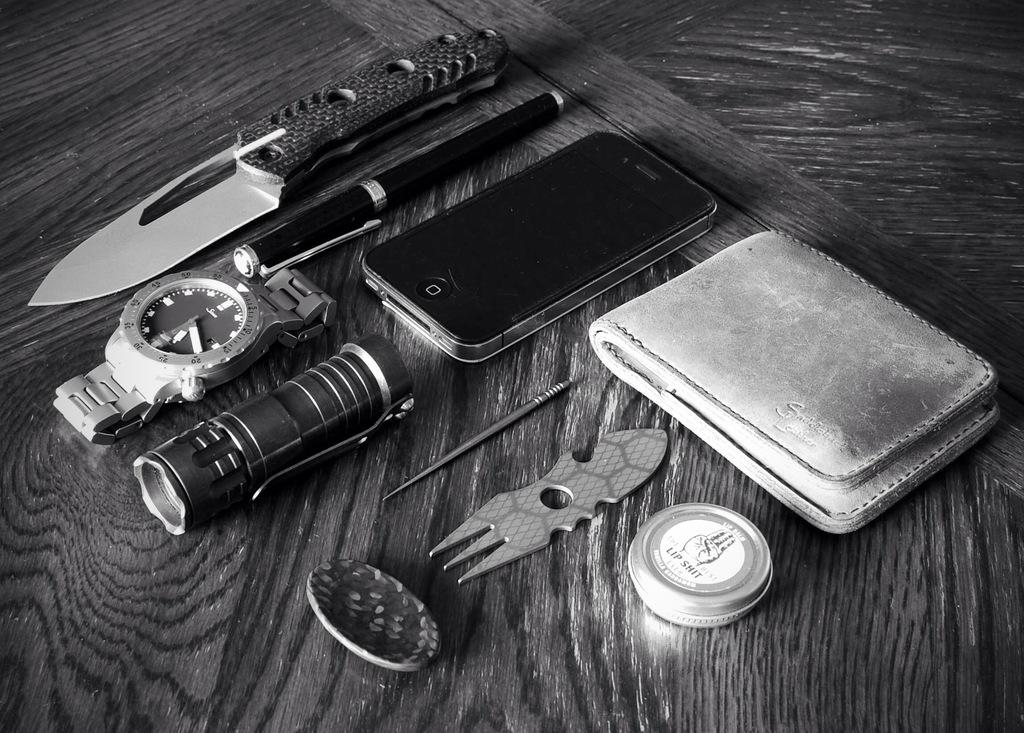<image>
Give a short and clear explanation of the subsequent image. Bunch of items together on a table including a watch that has the hands on numbers 12. 